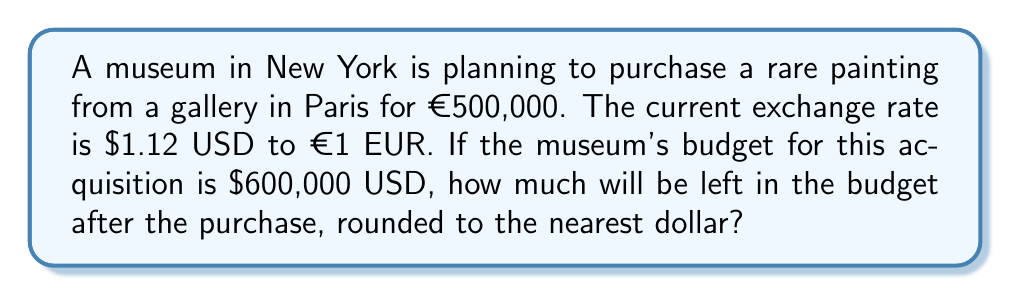Help me with this question. Let's approach this step-by-step:

1) First, we need to convert the price of the painting from Euros to US Dollars.
   
   Exchange rate: $1.12 USD = €1 EUR
   Price of painting: €500,000
   
   To convert, we multiply: 
   $$500,000 \times 1.12 = 560,000$$

   So, the price of the painting in USD is $560,000.

2) Now, we can calculate how much is left in the budget:
   
   Budget: $600,000
   Cost of painting: $560,000
   
   Remaining budget:
   $$600,000 - 560,000 = 40,000$$

3) The question asks for the answer rounded to the nearest dollar, but $40,000 is already a whole number, so no further rounding is necessary.
Answer: $40,000 